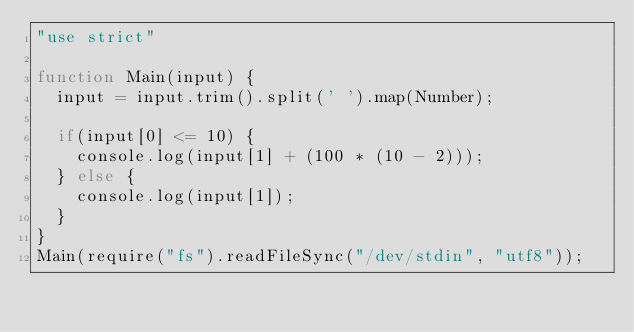<code> <loc_0><loc_0><loc_500><loc_500><_JavaScript_>"use strict"

function Main(input) {
  input = input.trim().split(' ').map(Number);

  if(input[0] <= 10) {
    console.log(input[1] + (100 * (10 - 2)));
  } else {
    console.log(input[1]);
  }
}
Main(require("fs").readFileSync("/dev/stdin", "utf8"));</code> 